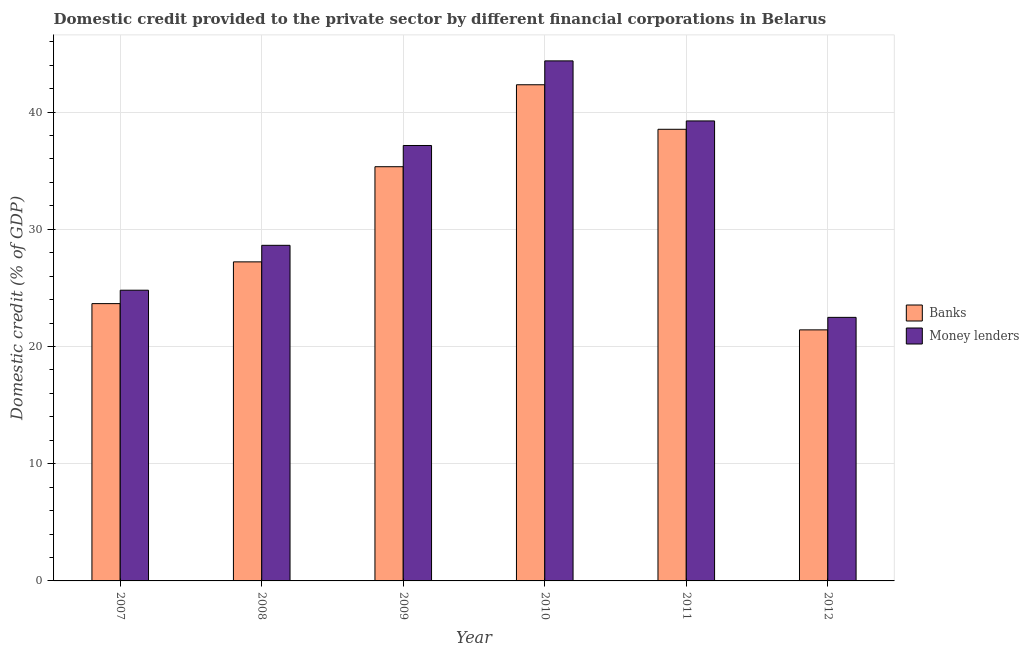How many different coloured bars are there?
Provide a succinct answer. 2. How many groups of bars are there?
Provide a succinct answer. 6. How many bars are there on the 5th tick from the left?
Your answer should be compact. 2. What is the label of the 5th group of bars from the left?
Keep it short and to the point. 2011. In how many cases, is the number of bars for a given year not equal to the number of legend labels?
Offer a terse response. 0. What is the domestic credit provided by money lenders in 2012?
Offer a very short reply. 22.49. Across all years, what is the maximum domestic credit provided by money lenders?
Your answer should be compact. 44.37. Across all years, what is the minimum domestic credit provided by banks?
Give a very brief answer. 21.42. What is the total domestic credit provided by money lenders in the graph?
Your answer should be compact. 196.69. What is the difference between the domestic credit provided by banks in 2011 and that in 2012?
Your answer should be compact. 17.11. What is the difference between the domestic credit provided by money lenders in 2009 and the domestic credit provided by banks in 2007?
Your response must be concise. 12.35. What is the average domestic credit provided by money lenders per year?
Give a very brief answer. 32.78. What is the ratio of the domestic credit provided by money lenders in 2007 to that in 2010?
Offer a very short reply. 0.56. Is the domestic credit provided by money lenders in 2008 less than that in 2010?
Provide a short and direct response. Yes. What is the difference between the highest and the second highest domestic credit provided by banks?
Provide a succinct answer. 3.8. What is the difference between the highest and the lowest domestic credit provided by banks?
Offer a very short reply. 20.91. Is the sum of the domestic credit provided by banks in 2009 and 2010 greater than the maximum domestic credit provided by money lenders across all years?
Provide a succinct answer. Yes. What does the 2nd bar from the left in 2012 represents?
Ensure brevity in your answer.  Money lenders. What does the 2nd bar from the right in 2010 represents?
Make the answer very short. Banks. How many bars are there?
Ensure brevity in your answer.  12. Does the graph contain grids?
Give a very brief answer. Yes. What is the title of the graph?
Provide a short and direct response. Domestic credit provided to the private sector by different financial corporations in Belarus. What is the label or title of the X-axis?
Provide a succinct answer. Year. What is the label or title of the Y-axis?
Your response must be concise. Domestic credit (% of GDP). What is the Domestic credit (% of GDP) in Banks in 2007?
Your response must be concise. 23.66. What is the Domestic credit (% of GDP) in Money lenders in 2007?
Provide a succinct answer. 24.8. What is the Domestic credit (% of GDP) of Banks in 2008?
Offer a very short reply. 27.22. What is the Domestic credit (% of GDP) of Money lenders in 2008?
Offer a very short reply. 28.63. What is the Domestic credit (% of GDP) in Banks in 2009?
Keep it short and to the point. 35.34. What is the Domestic credit (% of GDP) of Money lenders in 2009?
Your response must be concise. 37.15. What is the Domestic credit (% of GDP) of Banks in 2010?
Your response must be concise. 42.33. What is the Domestic credit (% of GDP) of Money lenders in 2010?
Your answer should be very brief. 44.37. What is the Domestic credit (% of GDP) of Banks in 2011?
Ensure brevity in your answer.  38.53. What is the Domestic credit (% of GDP) of Money lenders in 2011?
Provide a short and direct response. 39.25. What is the Domestic credit (% of GDP) in Banks in 2012?
Make the answer very short. 21.42. What is the Domestic credit (% of GDP) in Money lenders in 2012?
Your response must be concise. 22.49. Across all years, what is the maximum Domestic credit (% of GDP) in Banks?
Offer a terse response. 42.33. Across all years, what is the maximum Domestic credit (% of GDP) of Money lenders?
Make the answer very short. 44.37. Across all years, what is the minimum Domestic credit (% of GDP) in Banks?
Offer a terse response. 21.42. Across all years, what is the minimum Domestic credit (% of GDP) in Money lenders?
Provide a succinct answer. 22.49. What is the total Domestic credit (% of GDP) of Banks in the graph?
Keep it short and to the point. 188.51. What is the total Domestic credit (% of GDP) in Money lenders in the graph?
Keep it short and to the point. 196.69. What is the difference between the Domestic credit (% of GDP) in Banks in 2007 and that in 2008?
Offer a terse response. -3.56. What is the difference between the Domestic credit (% of GDP) in Money lenders in 2007 and that in 2008?
Your response must be concise. -3.83. What is the difference between the Domestic credit (% of GDP) in Banks in 2007 and that in 2009?
Provide a short and direct response. -11.68. What is the difference between the Domestic credit (% of GDP) of Money lenders in 2007 and that in 2009?
Ensure brevity in your answer.  -12.35. What is the difference between the Domestic credit (% of GDP) in Banks in 2007 and that in 2010?
Offer a very short reply. -18.67. What is the difference between the Domestic credit (% of GDP) of Money lenders in 2007 and that in 2010?
Offer a very short reply. -19.57. What is the difference between the Domestic credit (% of GDP) of Banks in 2007 and that in 2011?
Provide a short and direct response. -14.87. What is the difference between the Domestic credit (% of GDP) of Money lenders in 2007 and that in 2011?
Your answer should be very brief. -14.44. What is the difference between the Domestic credit (% of GDP) in Banks in 2007 and that in 2012?
Provide a short and direct response. 2.24. What is the difference between the Domestic credit (% of GDP) in Money lenders in 2007 and that in 2012?
Offer a very short reply. 2.32. What is the difference between the Domestic credit (% of GDP) in Banks in 2008 and that in 2009?
Provide a succinct answer. -8.12. What is the difference between the Domestic credit (% of GDP) of Money lenders in 2008 and that in 2009?
Offer a terse response. -8.52. What is the difference between the Domestic credit (% of GDP) in Banks in 2008 and that in 2010?
Give a very brief answer. -15.11. What is the difference between the Domestic credit (% of GDP) in Money lenders in 2008 and that in 2010?
Give a very brief answer. -15.74. What is the difference between the Domestic credit (% of GDP) in Banks in 2008 and that in 2011?
Give a very brief answer. -11.31. What is the difference between the Domestic credit (% of GDP) in Money lenders in 2008 and that in 2011?
Ensure brevity in your answer.  -10.61. What is the difference between the Domestic credit (% of GDP) in Banks in 2008 and that in 2012?
Make the answer very short. 5.8. What is the difference between the Domestic credit (% of GDP) of Money lenders in 2008 and that in 2012?
Offer a very short reply. 6.15. What is the difference between the Domestic credit (% of GDP) in Banks in 2009 and that in 2010?
Make the answer very short. -6.99. What is the difference between the Domestic credit (% of GDP) in Money lenders in 2009 and that in 2010?
Provide a succinct answer. -7.22. What is the difference between the Domestic credit (% of GDP) in Banks in 2009 and that in 2011?
Your response must be concise. -3.19. What is the difference between the Domestic credit (% of GDP) in Money lenders in 2009 and that in 2011?
Provide a short and direct response. -2.1. What is the difference between the Domestic credit (% of GDP) of Banks in 2009 and that in 2012?
Offer a very short reply. 13.92. What is the difference between the Domestic credit (% of GDP) in Money lenders in 2009 and that in 2012?
Make the answer very short. 14.66. What is the difference between the Domestic credit (% of GDP) in Banks in 2010 and that in 2011?
Your answer should be compact. 3.8. What is the difference between the Domestic credit (% of GDP) of Money lenders in 2010 and that in 2011?
Ensure brevity in your answer.  5.12. What is the difference between the Domestic credit (% of GDP) in Banks in 2010 and that in 2012?
Give a very brief answer. 20.91. What is the difference between the Domestic credit (% of GDP) of Money lenders in 2010 and that in 2012?
Your response must be concise. 21.88. What is the difference between the Domestic credit (% of GDP) in Banks in 2011 and that in 2012?
Make the answer very short. 17.11. What is the difference between the Domestic credit (% of GDP) in Money lenders in 2011 and that in 2012?
Offer a terse response. 16.76. What is the difference between the Domestic credit (% of GDP) in Banks in 2007 and the Domestic credit (% of GDP) in Money lenders in 2008?
Provide a succinct answer. -4.97. What is the difference between the Domestic credit (% of GDP) of Banks in 2007 and the Domestic credit (% of GDP) of Money lenders in 2009?
Offer a terse response. -13.49. What is the difference between the Domestic credit (% of GDP) in Banks in 2007 and the Domestic credit (% of GDP) in Money lenders in 2010?
Make the answer very short. -20.71. What is the difference between the Domestic credit (% of GDP) in Banks in 2007 and the Domestic credit (% of GDP) in Money lenders in 2011?
Your response must be concise. -15.59. What is the difference between the Domestic credit (% of GDP) of Banks in 2007 and the Domestic credit (% of GDP) of Money lenders in 2012?
Your response must be concise. 1.17. What is the difference between the Domestic credit (% of GDP) of Banks in 2008 and the Domestic credit (% of GDP) of Money lenders in 2009?
Provide a succinct answer. -9.93. What is the difference between the Domestic credit (% of GDP) in Banks in 2008 and the Domestic credit (% of GDP) in Money lenders in 2010?
Provide a succinct answer. -17.15. What is the difference between the Domestic credit (% of GDP) in Banks in 2008 and the Domestic credit (% of GDP) in Money lenders in 2011?
Offer a very short reply. -12.03. What is the difference between the Domestic credit (% of GDP) in Banks in 2008 and the Domestic credit (% of GDP) in Money lenders in 2012?
Provide a short and direct response. 4.74. What is the difference between the Domestic credit (% of GDP) of Banks in 2009 and the Domestic credit (% of GDP) of Money lenders in 2010?
Provide a succinct answer. -9.03. What is the difference between the Domestic credit (% of GDP) of Banks in 2009 and the Domestic credit (% of GDP) of Money lenders in 2011?
Make the answer very short. -3.91. What is the difference between the Domestic credit (% of GDP) in Banks in 2009 and the Domestic credit (% of GDP) in Money lenders in 2012?
Make the answer very short. 12.85. What is the difference between the Domestic credit (% of GDP) of Banks in 2010 and the Domestic credit (% of GDP) of Money lenders in 2011?
Offer a terse response. 3.09. What is the difference between the Domestic credit (% of GDP) in Banks in 2010 and the Domestic credit (% of GDP) in Money lenders in 2012?
Provide a succinct answer. 19.85. What is the difference between the Domestic credit (% of GDP) in Banks in 2011 and the Domestic credit (% of GDP) in Money lenders in 2012?
Provide a succinct answer. 16.05. What is the average Domestic credit (% of GDP) in Banks per year?
Offer a terse response. 31.42. What is the average Domestic credit (% of GDP) in Money lenders per year?
Your answer should be compact. 32.78. In the year 2007, what is the difference between the Domestic credit (% of GDP) in Banks and Domestic credit (% of GDP) in Money lenders?
Offer a terse response. -1.14. In the year 2008, what is the difference between the Domestic credit (% of GDP) in Banks and Domestic credit (% of GDP) in Money lenders?
Your response must be concise. -1.41. In the year 2009, what is the difference between the Domestic credit (% of GDP) in Banks and Domestic credit (% of GDP) in Money lenders?
Provide a short and direct response. -1.81. In the year 2010, what is the difference between the Domestic credit (% of GDP) of Banks and Domestic credit (% of GDP) of Money lenders?
Provide a succinct answer. -2.04. In the year 2011, what is the difference between the Domestic credit (% of GDP) in Banks and Domestic credit (% of GDP) in Money lenders?
Your answer should be very brief. -0.71. In the year 2012, what is the difference between the Domestic credit (% of GDP) in Banks and Domestic credit (% of GDP) in Money lenders?
Your response must be concise. -1.07. What is the ratio of the Domestic credit (% of GDP) of Banks in 2007 to that in 2008?
Make the answer very short. 0.87. What is the ratio of the Domestic credit (% of GDP) of Money lenders in 2007 to that in 2008?
Offer a very short reply. 0.87. What is the ratio of the Domestic credit (% of GDP) in Banks in 2007 to that in 2009?
Ensure brevity in your answer.  0.67. What is the ratio of the Domestic credit (% of GDP) of Money lenders in 2007 to that in 2009?
Give a very brief answer. 0.67. What is the ratio of the Domestic credit (% of GDP) of Banks in 2007 to that in 2010?
Your answer should be very brief. 0.56. What is the ratio of the Domestic credit (% of GDP) of Money lenders in 2007 to that in 2010?
Provide a short and direct response. 0.56. What is the ratio of the Domestic credit (% of GDP) of Banks in 2007 to that in 2011?
Ensure brevity in your answer.  0.61. What is the ratio of the Domestic credit (% of GDP) of Money lenders in 2007 to that in 2011?
Provide a succinct answer. 0.63. What is the ratio of the Domestic credit (% of GDP) of Banks in 2007 to that in 2012?
Your answer should be very brief. 1.1. What is the ratio of the Domestic credit (% of GDP) of Money lenders in 2007 to that in 2012?
Offer a terse response. 1.1. What is the ratio of the Domestic credit (% of GDP) in Banks in 2008 to that in 2009?
Offer a very short reply. 0.77. What is the ratio of the Domestic credit (% of GDP) of Money lenders in 2008 to that in 2009?
Your response must be concise. 0.77. What is the ratio of the Domestic credit (% of GDP) of Banks in 2008 to that in 2010?
Your response must be concise. 0.64. What is the ratio of the Domestic credit (% of GDP) in Money lenders in 2008 to that in 2010?
Your answer should be compact. 0.65. What is the ratio of the Domestic credit (% of GDP) of Banks in 2008 to that in 2011?
Provide a short and direct response. 0.71. What is the ratio of the Domestic credit (% of GDP) of Money lenders in 2008 to that in 2011?
Your answer should be very brief. 0.73. What is the ratio of the Domestic credit (% of GDP) in Banks in 2008 to that in 2012?
Your answer should be compact. 1.27. What is the ratio of the Domestic credit (% of GDP) of Money lenders in 2008 to that in 2012?
Your answer should be compact. 1.27. What is the ratio of the Domestic credit (% of GDP) of Banks in 2009 to that in 2010?
Your response must be concise. 0.83. What is the ratio of the Domestic credit (% of GDP) in Money lenders in 2009 to that in 2010?
Provide a succinct answer. 0.84. What is the ratio of the Domestic credit (% of GDP) of Banks in 2009 to that in 2011?
Ensure brevity in your answer.  0.92. What is the ratio of the Domestic credit (% of GDP) in Money lenders in 2009 to that in 2011?
Make the answer very short. 0.95. What is the ratio of the Domestic credit (% of GDP) in Banks in 2009 to that in 2012?
Make the answer very short. 1.65. What is the ratio of the Domestic credit (% of GDP) of Money lenders in 2009 to that in 2012?
Provide a short and direct response. 1.65. What is the ratio of the Domestic credit (% of GDP) of Banks in 2010 to that in 2011?
Your answer should be very brief. 1.1. What is the ratio of the Domestic credit (% of GDP) of Money lenders in 2010 to that in 2011?
Your answer should be very brief. 1.13. What is the ratio of the Domestic credit (% of GDP) in Banks in 2010 to that in 2012?
Make the answer very short. 1.98. What is the ratio of the Domestic credit (% of GDP) of Money lenders in 2010 to that in 2012?
Make the answer very short. 1.97. What is the ratio of the Domestic credit (% of GDP) of Banks in 2011 to that in 2012?
Give a very brief answer. 1.8. What is the ratio of the Domestic credit (% of GDP) in Money lenders in 2011 to that in 2012?
Your response must be concise. 1.75. What is the difference between the highest and the second highest Domestic credit (% of GDP) in Banks?
Keep it short and to the point. 3.8. What is the difference between the highest and the second highest Domestic credit (% of GDP) of Money lenders?
Give a very brief answer. 5.12. What is the difference between the highest and the lowest Domestic credit (% of GDP) of Banks?
Your response must be concise. 20.91. What is the difference between the highest and the lowest Domestic credit (% of GDP) in Money lenders?
Provide a short and direct response. 21.88. 